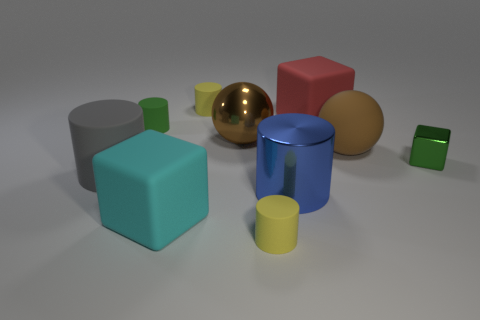How many objects are big cubes or tiny cylinders behind the green matte object?
Ensure brevity in your answer.  3. What color is the ball that is the same material as the big gray thing?
Provide a succinct answer. Brown. What number of objects are either big red spheres or big gray matte things?
Provide a short and direct response. 1. There is another rubber cube that is the same size as the red matte cube; what color is it?
Your response must be concise. Cyan. How many objects are either big cylinders that are left of the green cylinder or tiny matte things?
Make the answer very short. 4. What number of other objects are there of the same size as the green block?
Offer a very short reply. 3. What size is the yellow thing that is in front of the shiny ball?
Your response must be concise. Small. The green thing that is made of the same material as the big cyan cube is what shape?
Keep it short and to the point. Cylinder. Are there any other things that are the same color as the metallic ball?
Ensure brevity in your answer.  Yes. What color is the matte block that is right of the matte cylinder that is behind the small green matte cylinder?
Your answer should be very brief. Red. 